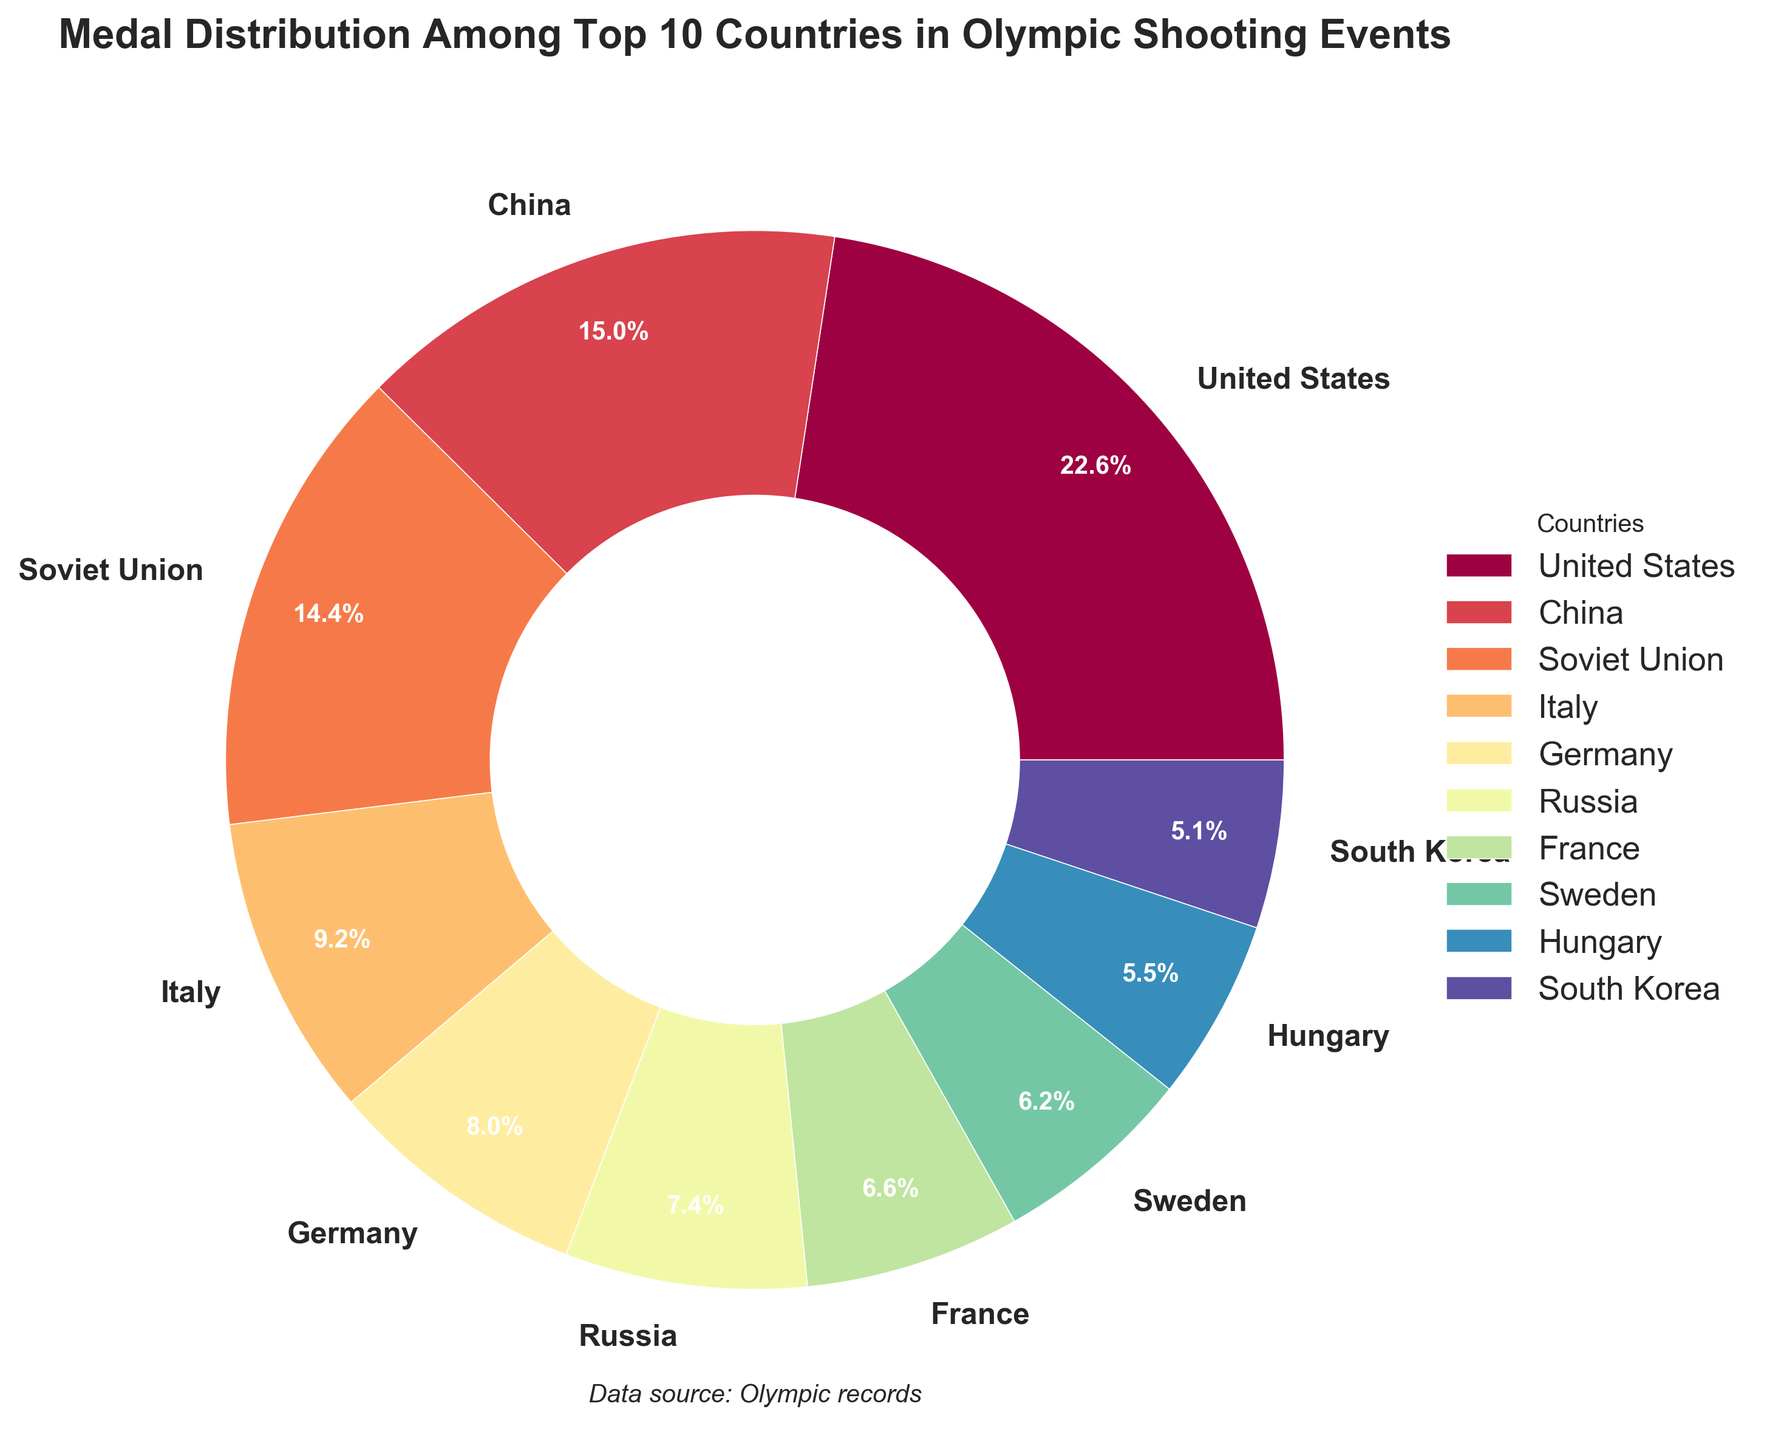Who has earned the most medals in Olympic shooting events according to the figure? The pie chart shows the medal distribution, and the largest segment represents the United States.
Answer: United States Which two countries together contribute to over 40% of the medals? The United States earned 110 medals and China earned 73 medals. To find their combined percentage, add their percentages: (110 + 73) out of the total. The chart displays percentages, showing they together exceed 40%.
Answer: United States and China How many more medals did the United States win than China? The figure shows that the United States won 110 medals and China won 73 medals. Subtract China's medals from the United States's medals. 110 - 73 = 37.
Answer: 37 What percentage of the total medals did Germany win? The pie chart shows the medal count and percentage for each country. Germany's share is directly shown on the chart as a percentage.
Answer: 7.7% Which country has the smallest share of medals and what is the percentage? From the pie chart, observe the smallest segment. South Korea is the smallest with a specific percentage directly indicated.
Answer: South Korea, 4.9% What is the combined percentage of medals won by Italy, Germany, and France? Add the shown percentages for Italy, Germany, and France. If Italy has 8.9%, Germany 7.7%, and France 6.3%, then sum these. 8.9 + 7.7 + 6.3 = 22.9.
Answer: 22.9% Compare the total number of medals won by the Soviet Union and Russia. Which one has more and by how many? The Soviet Union won 70 medals, and Russia won 36 medals. Subtract Russia's count from the Soviet Union's. 70 - 36 = 34.
Answer: Soviet Union, 34 What is the percentage difference between medals won by China and the Soviet Union? Both countries' percentages are shown in the pie chart. Subtract the Soviet Union's percentage from China's. If China's is 15.6% and the Soviet Union's is 15.0%, then the difference is 0.6%.
Answer: 0.6% What fraction of the medals do the top 3 countries together represent? Convert the percentages of the USA, China, and Soviet Union to fractions and sum them. The total of their percentages is 23.4% + 15.6% + 15.0%, which equals 54%. This percentage as a fraction is 54/100 which reduces to 27/50.
Answer: 27/50 